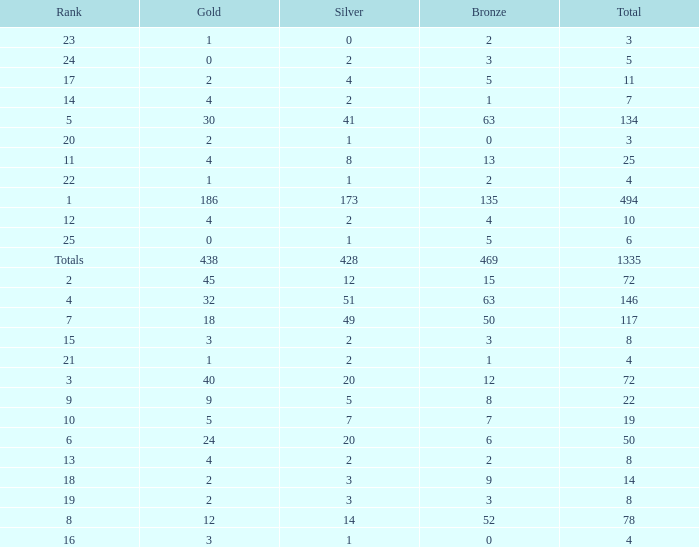What is the average number of gold medals when the total was 1335 medals, with more than 469 bronzes and more than 14 silvers? None. 